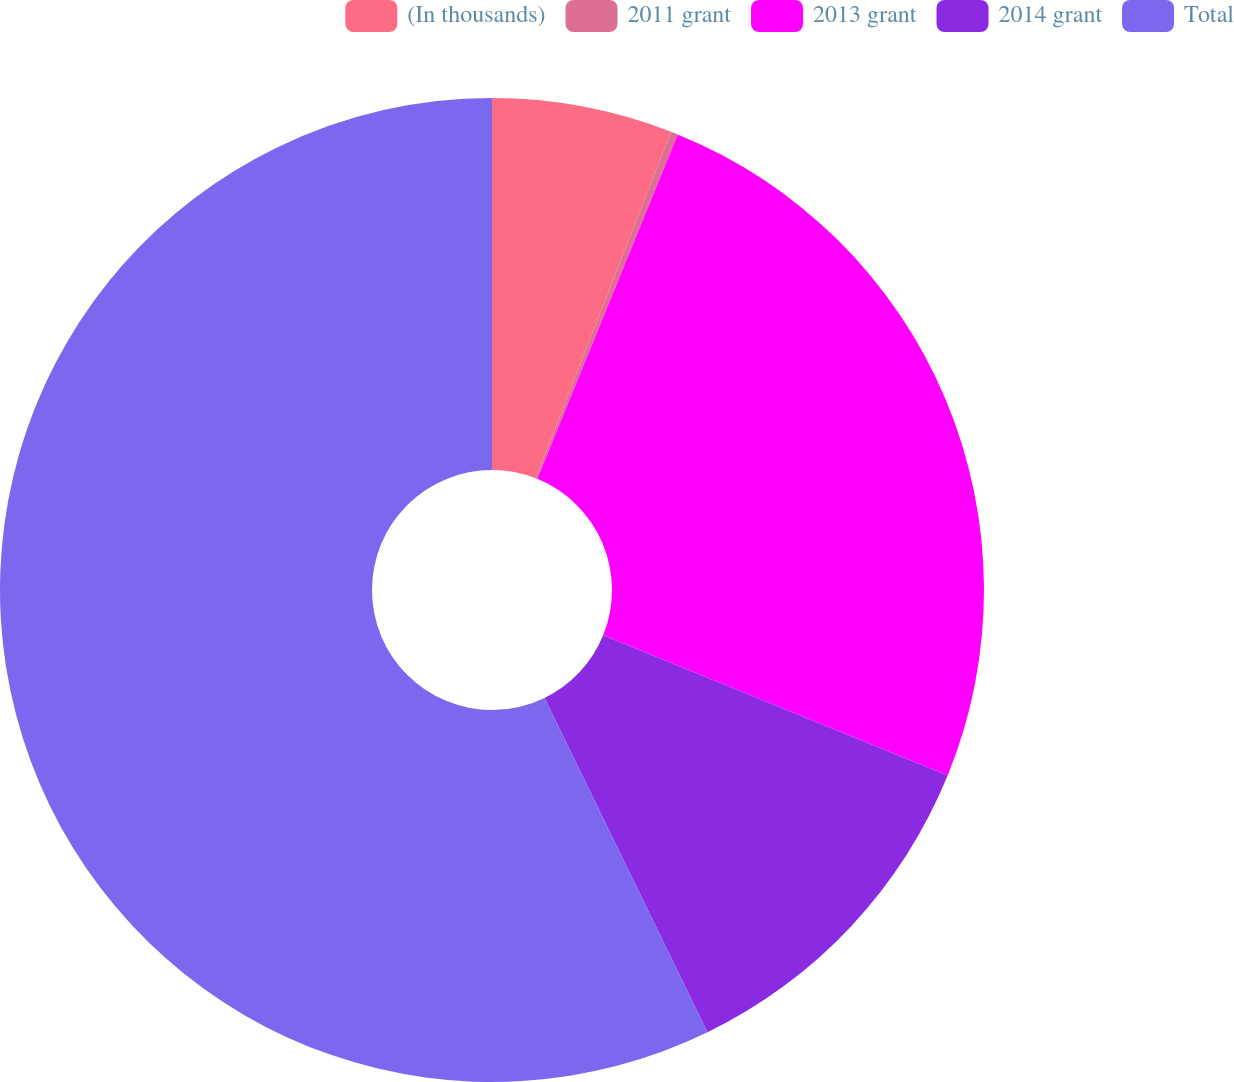Convert chart to OTSL. <chart><loc_0><loc_0><loc_500><loc_500><pie_chart><fcel>(In thousands)<fcel>2011 grant<fcel>2013 grant<fcel>2014 grant<fcel>Total<nl><fcel>5.93%<fcel>0.23%<fcel>25.0%<fcel>11.63%<fcel>57.22%<nl></chart> 